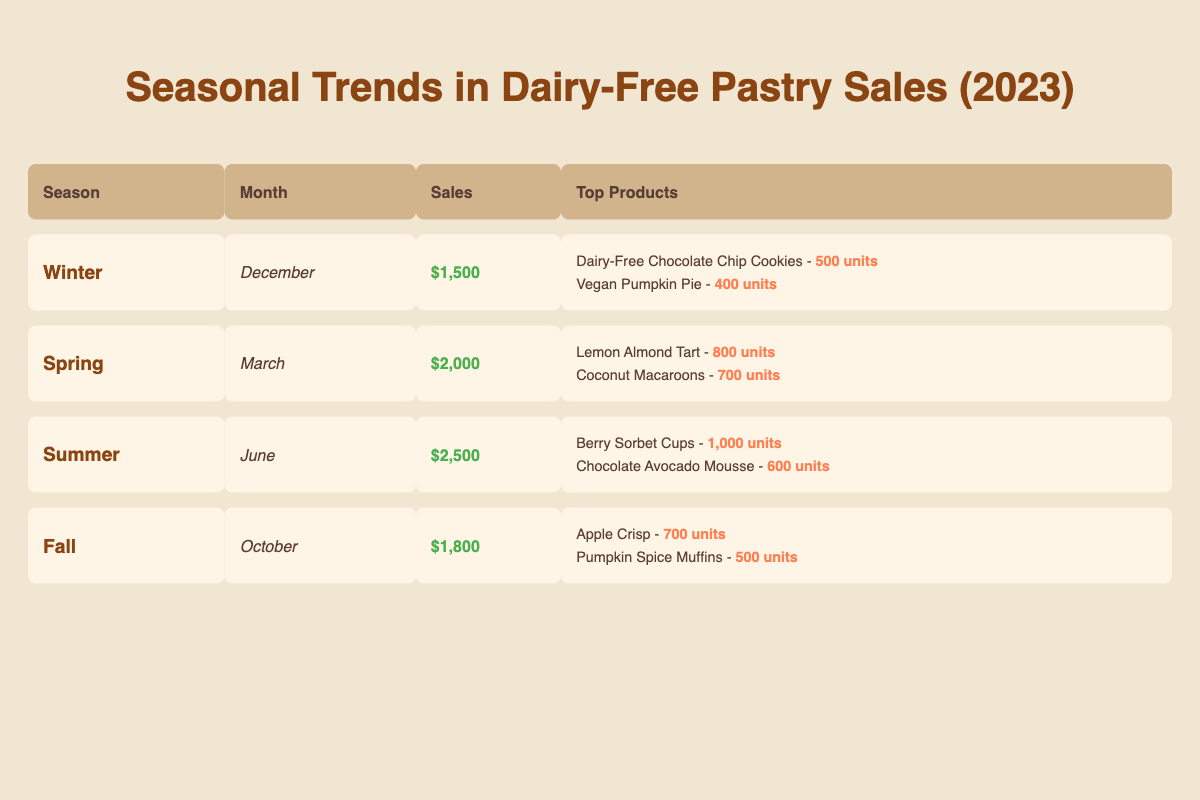What were the total sales for Spring 2023? The table shows that sales for Spring in March 2023 are $2,000. Therefore, the total sales for Spring 2023 is simply the value provided under that season.
Answer: 2000 Which month had the highest sales in 2023? By reviewing the sales figures listed for each season, Winter had $1,500, Spring had $2,000, Summer had $2,500, and Fall had $1,800. Clearly, the maximum sales figure is $2,500 in Summer.
Answer: 2500 How many units of Dairy-Free Chocolate Chip Cookies were sold in Winter 2023? The table specifies that during Winter in December 2023, 500 units of Dairy-Free Chocolate Chip Cookies were sold directly under the "Top Products" section.
Answer: 500 Is the total number of units sold for the top products in Summer greater than that of Fall? Summer’s top products are Berry Sorbet Cups (1,000 units) and Chocolate Avocado Mousse (600 units), totaling 1,600 units. Fall’s top products are Apple Crisp (700 units) and Pumpkin Spice Muffins (500 units), totaling 1,200 units. Since 1,600 is greater than 1,200, the statement is true.
Answer: Yes What is the difference in sales between Spring and Winter? The sales for Spring in March is $2,000, and for Winter in December, it is $1,500. To find the difference, we subtract Winter's sales from Spring's: $2,000 - $1,500 = $500.
Answer: 500 Which season had the least sales in 2023? By analyzing the sales figures across all the seasons, Winter had $1,500, Spring had $2,000, Summer had $2,500, and Fall had $1,800. Winter has the lowest sales amount, so it is the season with the least sales.
Answer: Winter What is the combined total unit sales for the top products in Spring? In Spring, the top products listed are Lemon Almond Tart (800 units) and Coconut Macaroons (700 units), making a combined total of 800 + 700 = 1,500 units sold.
Answer: 1500 Is Vegan Pumpkin Pie listed as one of the top products in any season? Checking the table, Vegan Pumpkin Pie appears under Winter's top products with 400 units sold. Thus, the answer is yes.
Answer: Yes What is the average sales amount per season for 2023? The total sales across all seasons are $1,500 (Winter) + $2,000 (Spring) + $2,500 (Summer) + $1,800 (Fall) = $8,800. There are four seasons, so the average sales amount is calculated by dividing total sales by the number of seasons: $8,800 / 4 = $2,200.
Answer: 2200 